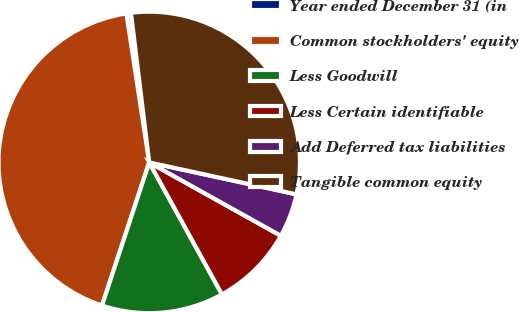Convert chart to OTSL. <chart><loc_0><loc_0><loc_500><loc_500><pie_chart><fcel>Year ended December 31 (in<fcel>Common stockholders' equity<fcel>Less Goodwill<fcel>Less Certain identifiable<fcel>Add Deferred tax liabilities<fcel>Tangible common equity<nl><fcel>0.49%<fcel>42.5%<fcel>13.09%<fcel>8.89%<fcel>4.69%<fcel>30.33%<nl></chart> 